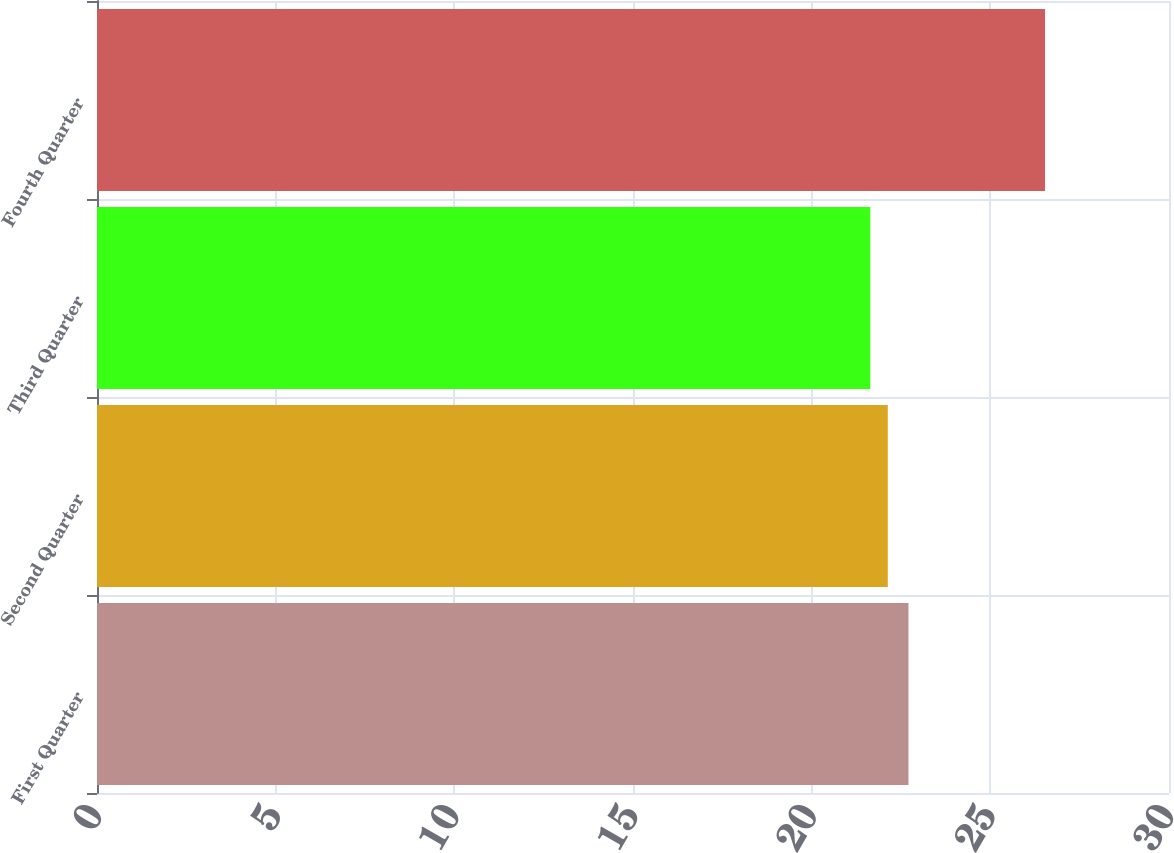Convert chart to OTSL. <chart><loc_0><loc_0><loc_500><loc_500><bar_chart><fcel>First Quarter<fcel>Second Quarter<fcel>Third Quarter<fcel>Fourth Quarter<nl><fcel>22.71<fcel>22.13<fcel>21.64<fcel>26.53<nl></chart> 